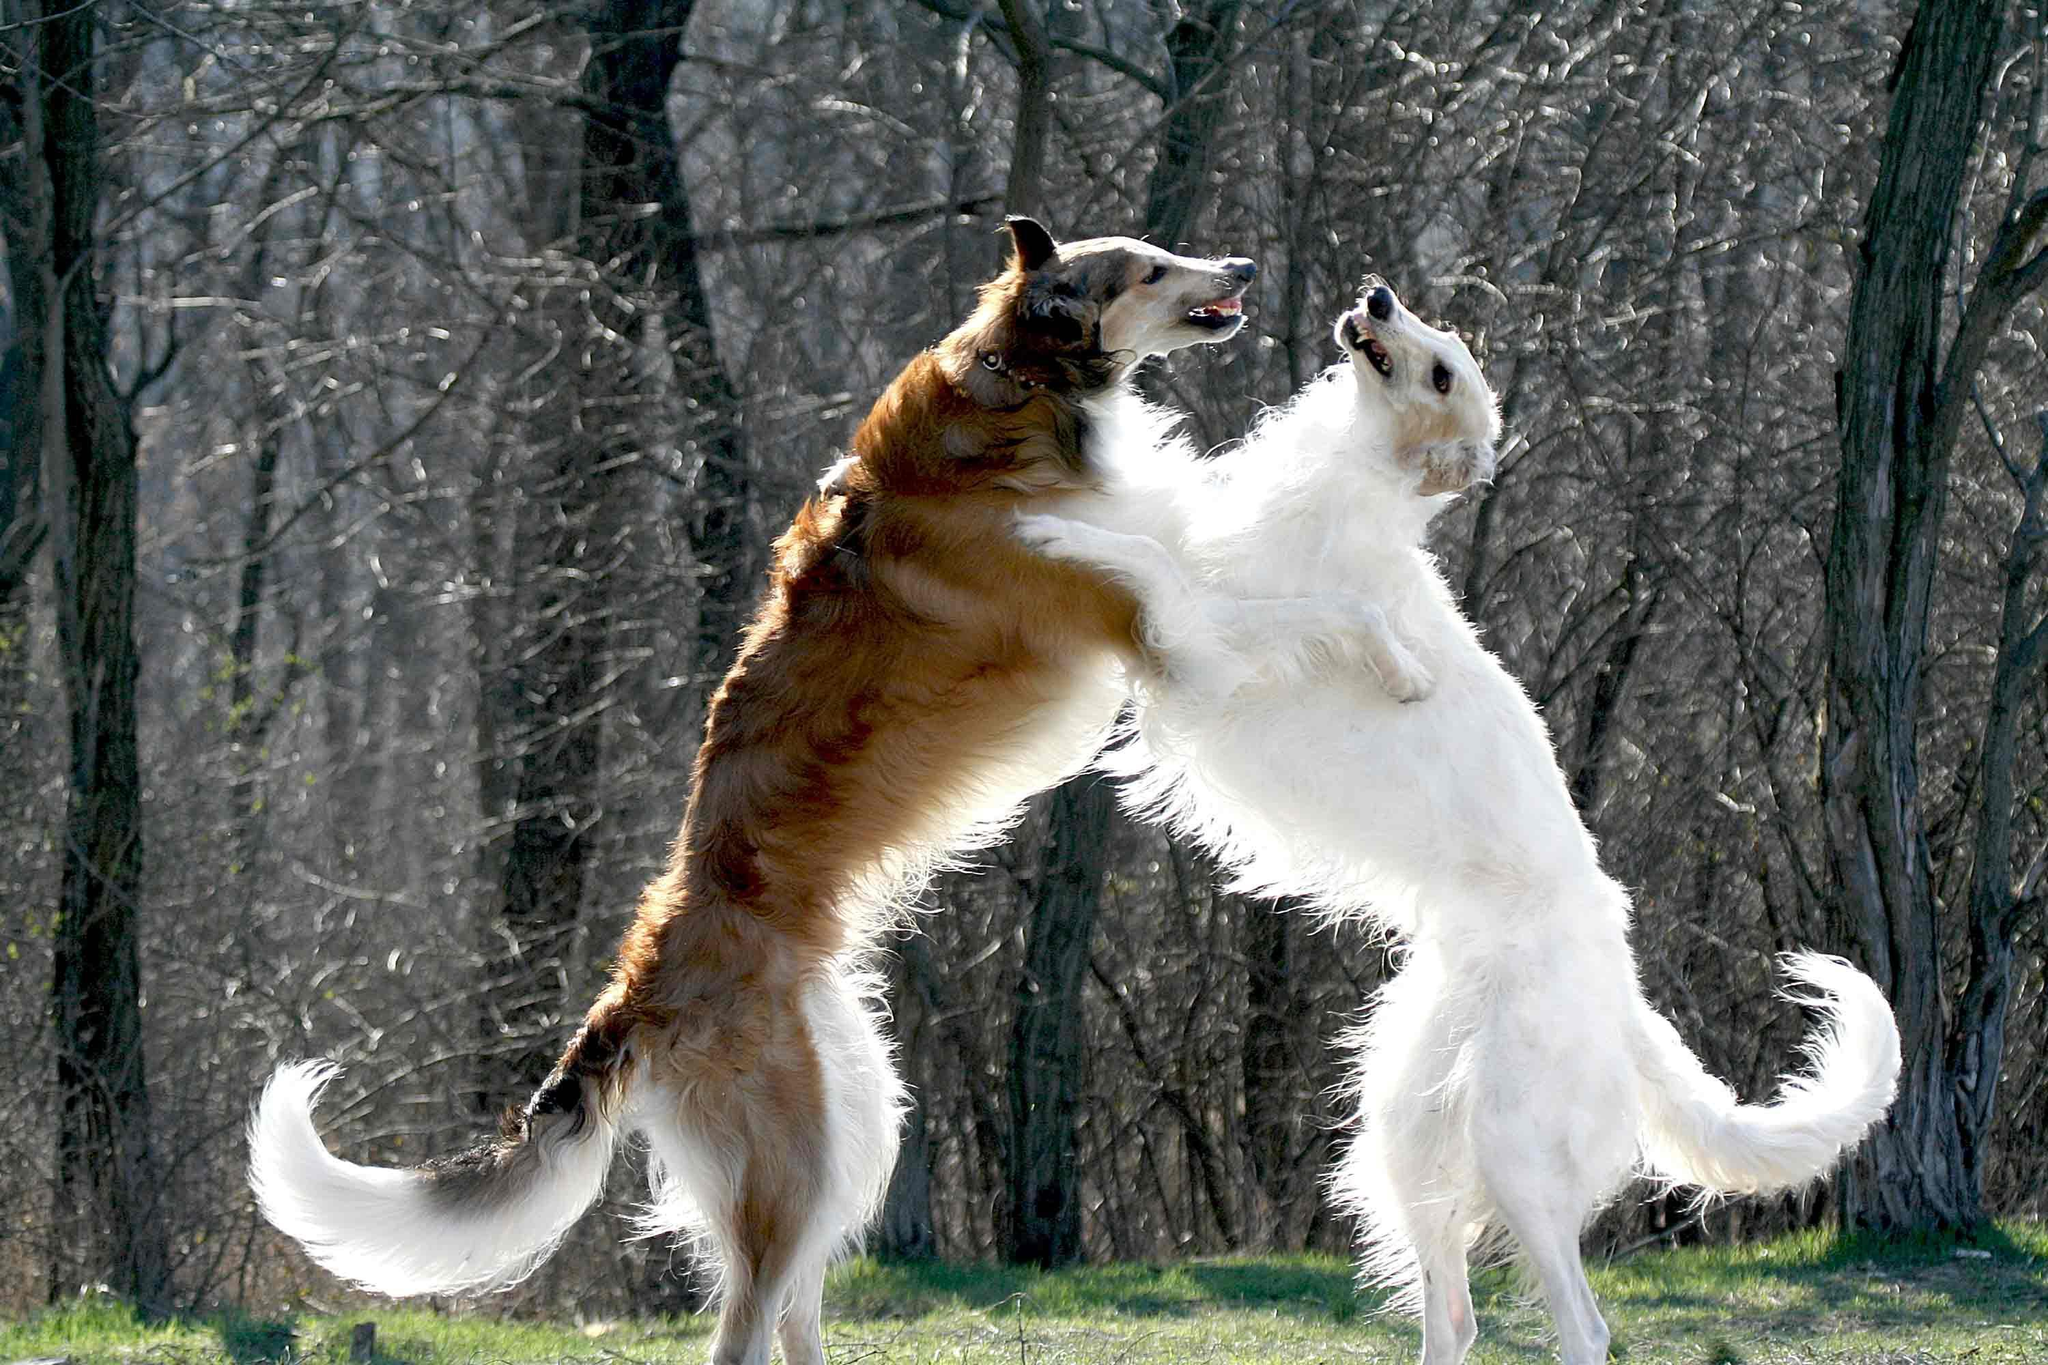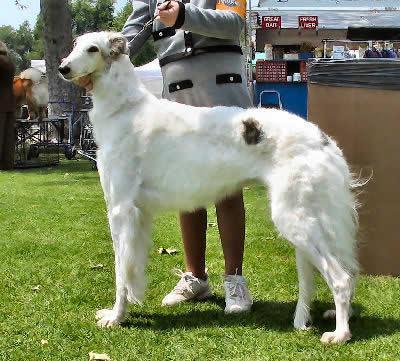The first image is the image on the left, the second image is the image on the right. For the images displayed, is the sentence "Each image features one dog, and the dogs are facing opposite directions." factually correct? Answer yes or no. No. The first image is the image on the left, the second image is the image on the right. Given the left and right images, does the statement "there is only one human on the image." hold true? Answer yes or no. Yes. 